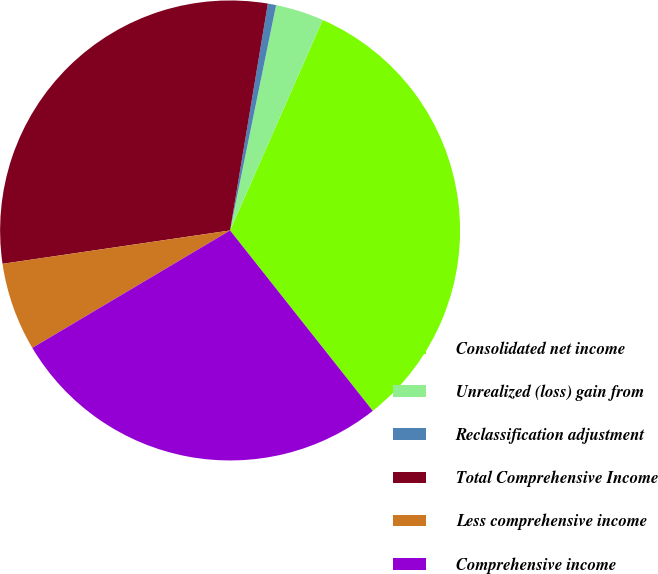Convert chart to OTSL. <chart><loc_0><loc_0><loc_500><loc_500><pie_chart><fcel>Consolidated net income<fcel>Unrealized (loss) gain from<fcel>Reclassification adjustment<fcel>Total Comprehensive Income<fcel>Less comprehensive income<fcel>Comprehensive income<nl><fcel>32.75%<fcel>3.39%<fcel>0.58%<fcel>29.94%<fcel>6.21%<fcel>27.12%<nl></chart> 